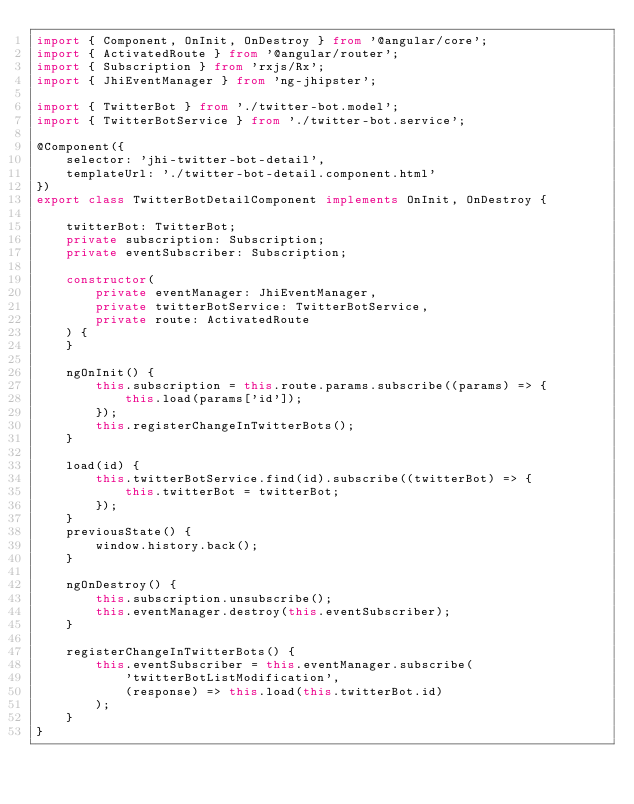Convert code to text. <code><loc_0><loc_0><loc_500><loc_500><_TypeScript_>import { Component, OnInit, OnDestroy } from '@angular/core';
import { ActivatedRoute } from '@angular/router';
import { Subscription } from 'rxjs/Rx';
import { JhiEventManager } from 'ng-jhipster';

import { TwitterBot } from './twitter-bot.model';
import { TwitterBotService } from './twitter-bot.service';

@Component({
    selector: 'jhi-twitter-bot-detail',
    templateUrl: './twitter-bot-detail.component.html'
})
export class TwitterBotDetailComponent implements OnInit, OnDestroy {

    twitterBot: TwitterBot;
    private subscription: Subscription;
    private eventSubscriber: Subscription;

    constructor(
        private eventManager: JhiEventManager,
        private twitterBotService: TwitterBotService,
        private route: ActivatedRoute
    ) {
    }

    ngOnInit() {
        this.subscription = this.route.params.subscribe((params) => {
            this.load(params['id']);
        });
        this.registerChangeInTwitterBots();
    }

    load(id) {
        this.twitterBotService.find(id).subscribe((twitterBot) => {
            this.twitterBot = twitterBot;
        });
    }
    previousState() {
        window.history.back();
    }

    ngOnDestroy() {
        this.subscription.unsubscribe();
        this.eventManager.destroy(this.eventSubscriber);
    }

    registerChangeInTwitterBots() {
        this.eventSubscriber = this.eventManager.subscribe(
            'twitterBotListModification',
            (response) => this.load(this.twitterBot.id)
        );
    }
}
</code> 